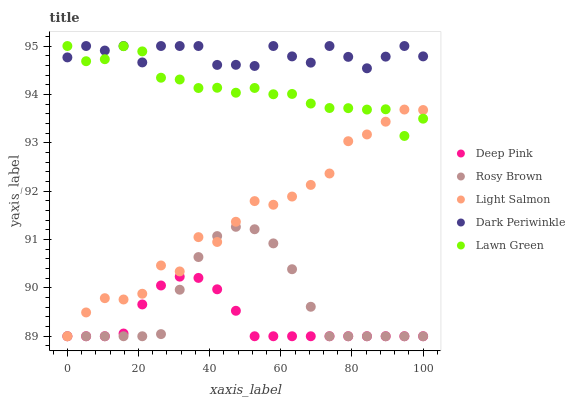Does Deep Pink have the minimum area under the curve?
Answer yes or no. Yes. Does Dark Periwinkle have the maximum area under the curve?
Answer yes or no. Yes. Does Rosy Brown have the minimum area under the curve?
Answer yes or no. No. Does Rosy Brown have the maximum area under the curve?
Answer yes or no. No. Is Deep Pink the smoothest?
Answer yes or no. Yes. Is Light Salmon the roughest?
Answer yes or no. Yes. Is Rosy Brown the smoothest?
Answer yes or no. No. Is Rosy Brown the roughest?
Answer yes or no. No. Does Rosy Brown have the lowest value?
Answer yes or no. Yes. Does Dark Periwinkle have the lowest value?
Answer yes or no. No. Does Dark Periwinkle have the highest value?
Answer yes or no. Yes. Does Rosy Brown have the highest value?
Answer yes or no. No. Is Deep Pink less than Dark Periwinkle?
Answer yes or no. Yes. Is Lawn Green greater than Rosy Brown?
Answer yes or no. Yes. Does Rosy Brown intersect Deep Pink?
Answer yes or no. Yes. Is Rosy Brown less than Deep Pink?
Answer yes or no. No. Is Rosy Brown greater than Deep Pink?
Answer yes or no. No. Does Deep Pink intersect Dark Periwinkle?
Answer yes or no. No. 